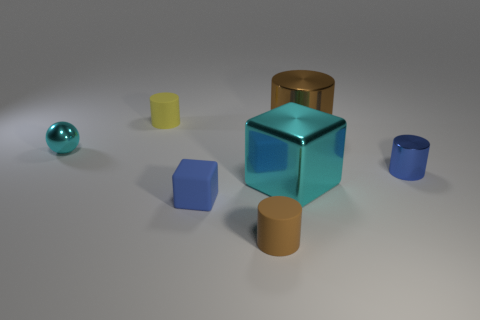There is a metal thing that is the same color as the small cube; what is its size?
Your answer should be very brief. Small. There is a object that is the same color as the small matte block; what shape is it?
Provide a short and direct response. Cylinder. How many tiny blocks are the same color as the tiny metal cylinder?
Your answer should be very brief. 1. There is a metallic thing that is left of the small blue cylinder and on the right side of the large block; how big is it?
Your response must be concise. Large. Are there any metal balls that are left of the cyan metal thing that is right of the cyan thing that is left of the yellow cylinder?
Give a very brief answer. Yes. There is a brown object in front of the big brown metal cylinder; is it the same shape as the tiny thing right of the big brown metallic cylinder?
Offer a very short reply. Yes. The small object that is the same material as the small cyan sphere is what color?
Provide a short and direct response. Blue. Are there fewer rubber blocks that are behind the cyan cube than small things?
Your response must be concise. Yes. What is the size of the cyan object right of the small matte cylinder that is behind the metal object right of the brown metal cylinder?
Your answer should be very brief. Large. Are the cyan thing that is on the right side of the metallic sphere and the tiny yellow object made of the same material?
Keep it short and to the point. No. 